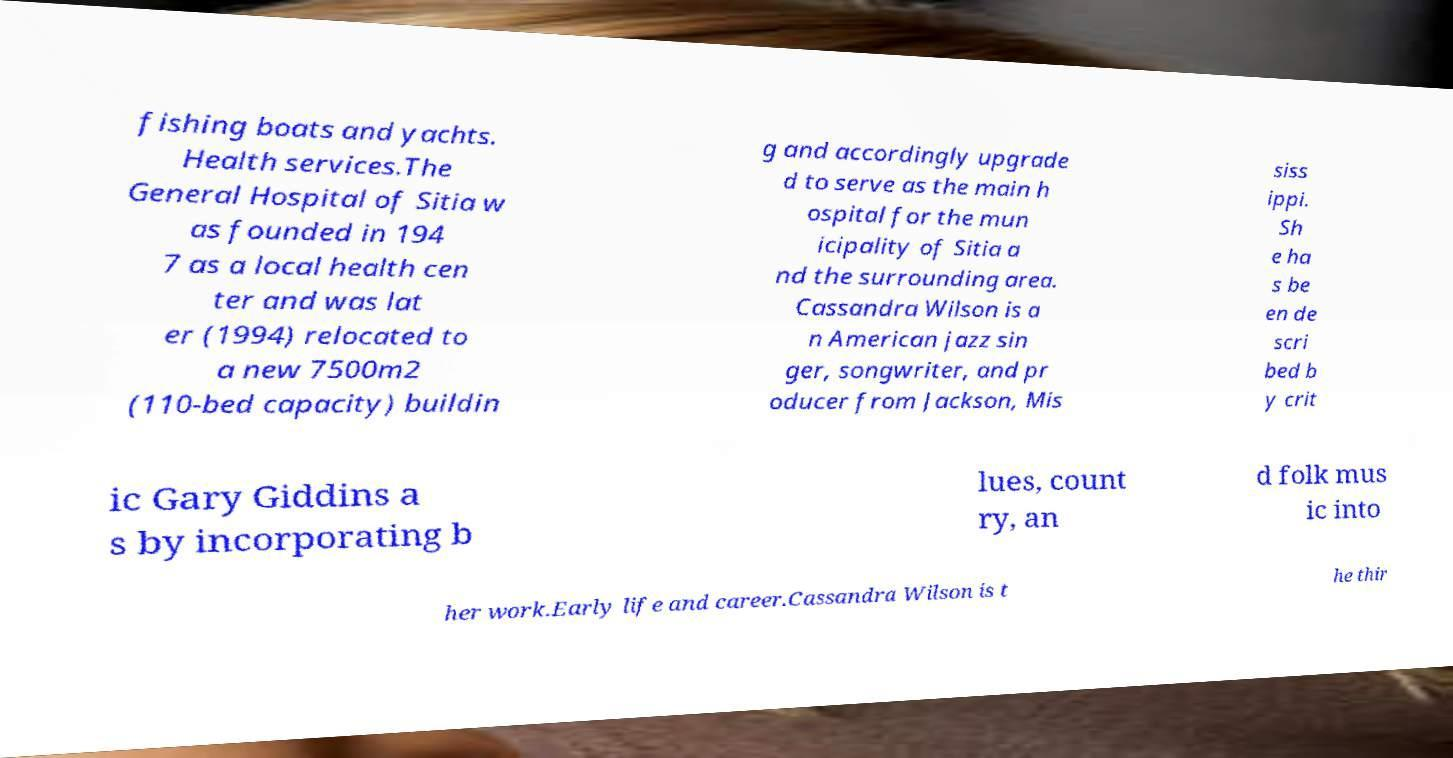Please read and relay the text visible in this image. What does it say? fishing boats and yachts. Health services.The General Hospital of Sitia w as founded in 194 7 as a local health cen ter and was lat er (1994) relocated to a new 7500m2 (110-bed capacity) buildin g and accordingly upgrade d to serve as the main h ospital for the mun icipality of Sitia a nd the surrounding area. Cassandra Wilson is a n American jazz sin ger, songwriter, and pr oducer from Jackson, Mis siss ippi. Sh e ha s be en de scri bed b y crit ic Gary Giddins a s by incorporating b lues, count ry, an d folk mus ic into her work.Early life and career.Cassandra Wilson is t he thir 